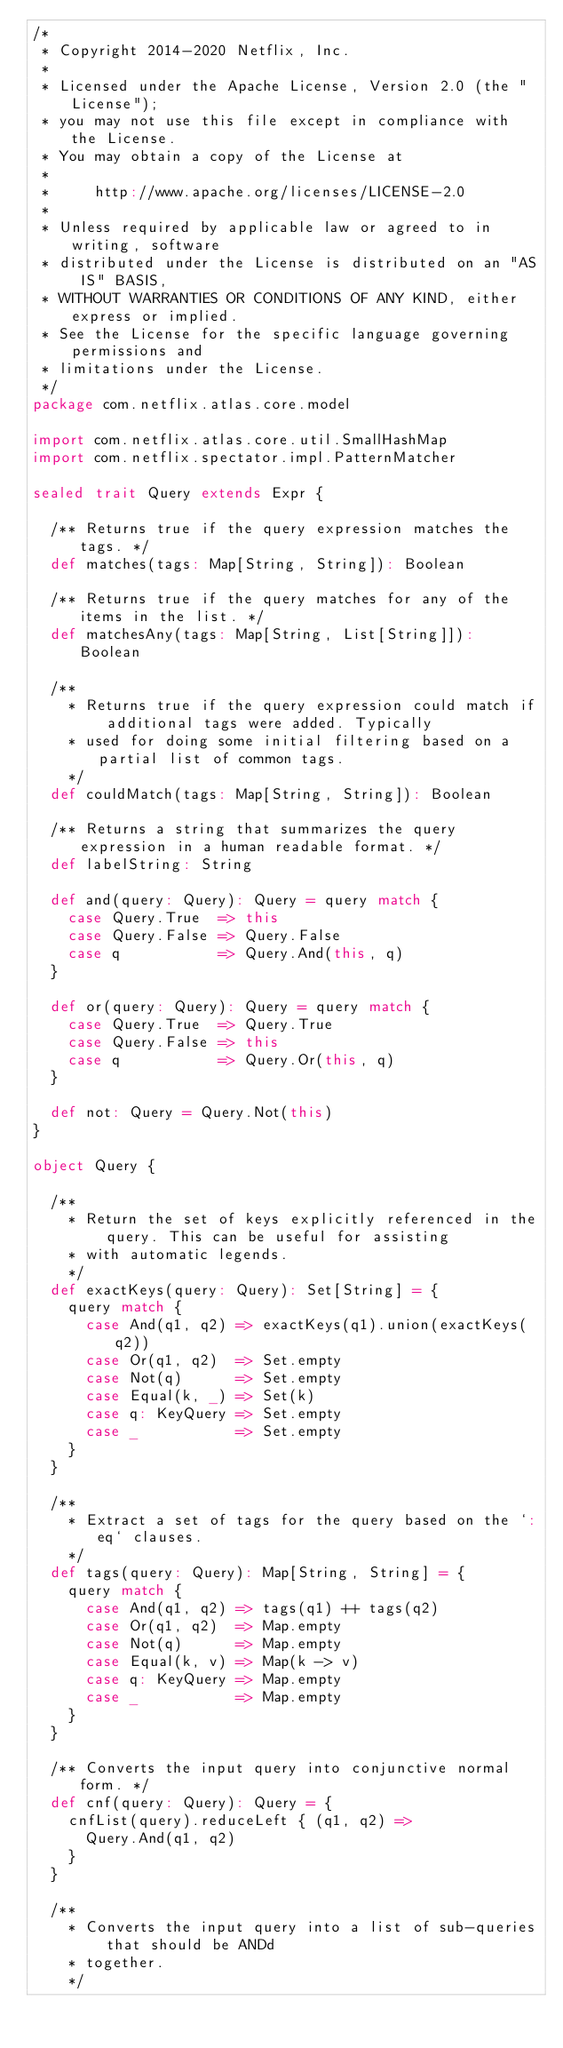<code> <loc_0><loc_0><loc_500><loc_500><_Scala_>/*
 * Copyright 2014-2020 Netflix, Inc.
 *
 * Licensed under the Apache License, Version 2.0 (the "License");
 * you may not use this file except in compliance with the License.
 * You may obtain a copy of the License at
 *
 *     http://www.apache.org/licenses/LICENSE-2.0
 *
 * Unless required by applicable law or agreed to in writing, software
 * distributed under the License is distributed on an "AS IS" BASIS,
 * WITHOUT WARRANTIES OR CONDITIONS OF ANY KIND, either express or implied.
 * See the License for the specific language governing permissions and
 * limitations under the License.
 */
package com.netflix.atlas.core.model

import com.netflix.atlas.core.util.SmallHashMap
import com.netflix.spectator.impl.PatternMatcher

sealed trait Query extends Expr {

  /** Returns true if the query expression matches the tags. */
  def matches(tags: Map[String, String]): Boolean

  /** Returns true if the query matches for any of the items in the list. */
  def matchesAny(tags: Map[String, List[String]]): Boolean

  /**
    * Returns true if the query expression could match if additional tags were added. Typically
    * used for doing some initial filtering based on a partial list of common tags.
    */
  def couldMatch(tags: Map[String, String]): Boolean

  /** Returns a string that summarizes the query expression in a human readable format. */
  def labelString: String

  def and(query: Query): Query = query match {
    case Query.True  => this
    case Query.False => Query.False
    case q           => Query.And(this, q)
  }

  def or(query: Query): Query = query match {
    case Query.True  => Query.True
    case Query.False => this
    case q           => Query.Or(this, q)
  }

  def not: Query = Query.Not(this)
}

object Query {

  /**
    * Return the set of keys explicitly referenced in the query. This can be useful for assisting
    * with automatic legends.
    */
  def exactKeys(query: Query): Set[String] = {
    query match {
      case And(q1, q2) => exactKeys(q1).union(exactKeys(q2))
      case Or(q1, q2)  => Set.empty
      case Not(q)      => Set.empty
      case Equal(k, _) => Set(k)
      case q: KeyQuery => Set.empty
      case _           => Set.empty
    }
  }

  /**
    * Extract a set of tags for the query based on the `:eq` clauses.
    */
  def tags(query: Query): Map[String, String] = {
    query match {
      case And(q1, q2) => tags(q1) ++ tags(q2)
      case Or(q1, q2)  => Map.empty
      case Not(q)      => Map.empty
      case Equal(k, v) => Map(k -> v)
      case q: KeyQuery => Map.empty
      case _           => Map.empty
    }
  }

  /** Converts the input query into conjunctive normal form. */
  def cnf(query: Query): Query = {
    cnfList(query).reduceLeft { (q1, q2) =>
      Query.And(q1, q2)
    }
  }

  /**
    * Converts the input query into a list of sub-queries that should be ANDd
    * together.
    */</code> 